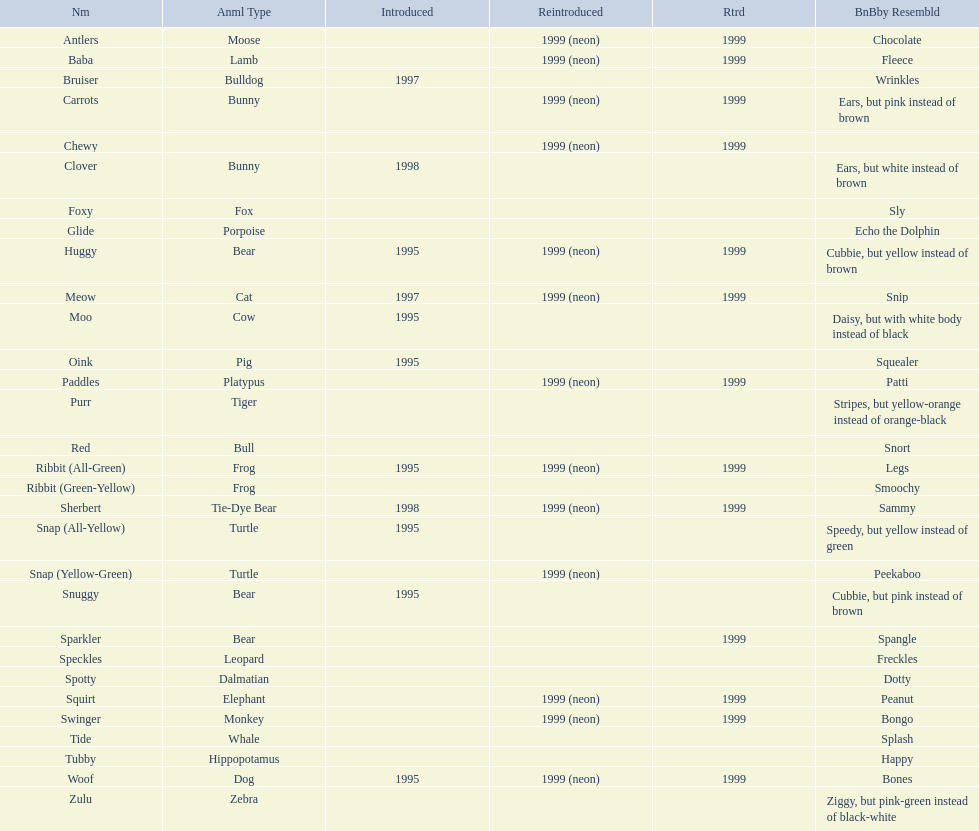What are the total number of pillow pals on this chart? 30. 